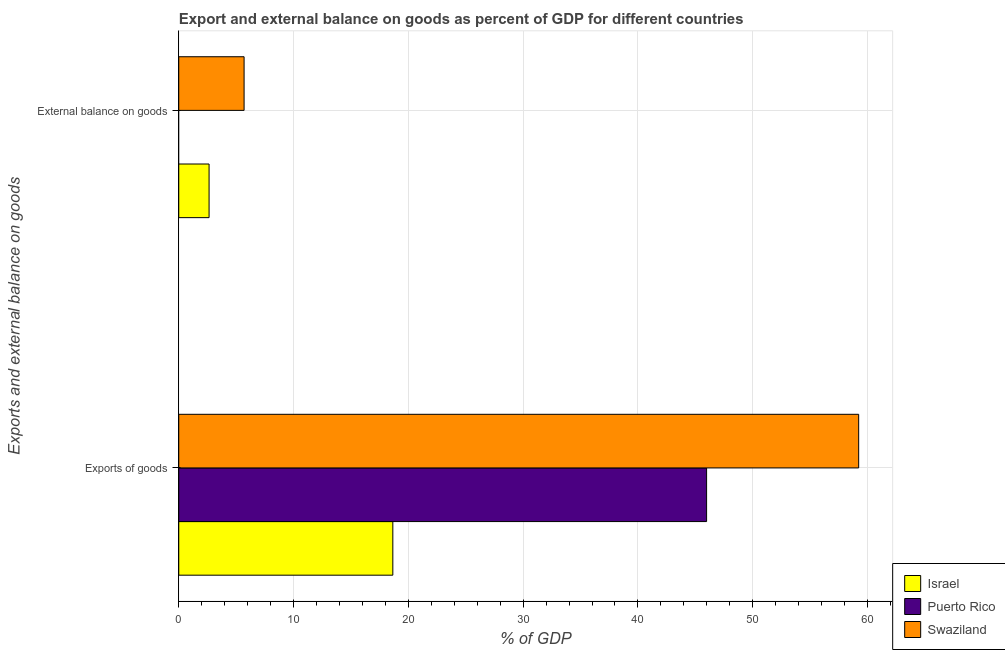Are the number of bars on each tick of the Y-axis equal?
Keep it short and to the point. No. What is the label of the 1st group of bars from the top?
Provide a short and direct response. External balance on goods. What is the export of goods as percentage of gdp in Swaziland?
Provide a short and direct response. 59.23. Across all countries, what is the maximum external balance on goods as percentage of gdp?
Offer a very short reply. 5.69. Across all countries, what is the minimum external balance on goods as percentage of gdp?
Provide a succinct answer. 0. In which country was the export of goods as percentage of gdp maximum?
Ensure brevity in your answer.  Swaziland. What is the total external balance on goods as percentage of gdp in the graph?
Offer a terse response. 8.33. What is the difference between the export of goods as percentage of gdp in Swaziland and that in Israel?
Offer a very short reply. 40.58. What is the difference between the external balance on goods as percentage of gdp in Israel and the export of goods as percentage of gdp in Swaziland?
Ensure brevity in your answer.  -56.59. What is the average external balance on goods as percentage of gdp per country?
Make the answer very short. 2.78. What is the difference between the external balance on goods as percentage of gdp and export of goods as percentage of gdp in Israel?
Give a very brief answer. -16.01. In how many countries, is the external balance on goods as percentage of gdp greater than 18 %?
Keep it short and to the point. 0. What is the ratio of the external balance on goods as percentage of gdp in Israel to that in Swaziland?
Your answer should be very brief. 0.46. How many bars are there?
Give a very brief answer. 5. Are all the bars in the graph horizontal?
Keep it short and to the point. Yes. How many countries are there in the graph?
Keep it short and to the point. 3. What is the difference between two consecutive major ticks on the X-axis?
Keep it short and to the point. 10. Are the values on the major ticks of X-axis written in scientific E-notation?
Keep it short and to the point. No. Does the graph contain grids?
Make the answer very short. Yes. How many legend labels are there?
Give a very brief answer. 3. How are the legend labels stacked?
Provide a succinct answer. Vertical. What is the title of the graph?
Your answer should be very brief. Export and external balance on goods as percent of GDP for different countries. What is the label or title of the X-axis?
Your answer should be very brief. % of GDP. What is the label or title of the Y-axis?
Ensure brevity in your answer.  Exports and external balance on goods. What is the % of GDP of Israel in Exports of goods?
Provide a succinct answer. 18.65. What is the % of GDP of Puerto Rico in Exports of goods?
Provide a succinct answer. 45.98. What is the % of GDP of Swaziland in Exports of goods?
Provide a short and direct response. 59.23. What is the % of GDP in Israel in External balance on goods?
Provide a short and direct response. 2.64. What is the % of GDP of Puerto Rico in External balance on goods?
Your answer should be very brief. 0. What is the % of GDP in Swaziland in External balance on goods?
Make the answer very short. 5.69. Across all Exports and external balance on goods, what is the maximum % of GDP in Israel?
Your answer should be compact. 18.65. Across all Exports and external balance on goods, what is the maximum % of GDP in Puerto Rico?
Your answer should be very brief. 45.98. Across all Exports and external balance on goods, what is the maximum % of GDP in Swaziland?
Provide a succinct answer. 59.23. Across all Exports and external balance on goods, what is the minimum % of GDP of Israel?
Offer a terse response. 2.64. Across all Exports and external balance on goods, what is the minimum % of GDP of Puerto Rico?
Keep it short and to the point. 0. Across all Exports and external balance on goods, what is the minimum % of GDP in Swaziland?
Your answer should be very brief. 5.69. What is the total % of GDP in Israel in the graph?
Provide a short and direct response. 21.29. What is the total % of GDP of Puerto Rico in the graph?
Your answer should be compact. 45.98. What is the total % of GDP in Swaziland in the graph?
Provide a short and direct response. 64.92. What is the difference between the % of GDP of Israel in Exports of goods and that in External balance on goods?
Your response must be concise. 16.01. What is the difference between the % of GDP of Swaziland in Exports of goods and that in External balance on goods?
Your answer should be very brief. 53.54. What is the difference between the % of GDP of Israel in Exports of goods and the % of GDP of Swaziland in External balance on goods?
Your response must be concise. 12.96. What is the difference between the % of GDP of Puerto Rico in Exports of goods and the % of GDP of Swaziland in External balance on goods?
Provide a short and direct response. 40.29. What is the average % of GDP of Israel per Exports and external balance on goods?
Your answer should be very brief. 10.64. What is the average % of GDP of Puerto Rico per Exports and external balance on goods?
Offer a terse response. 22.99. What is the average % of GDP in Swaziland per Exports and external balance on goods?
Provide a short and direct response. 32.46. What is the difference between the % of GDP of Israel and % of GDP of Puerto Rico in Exports of goods?
Offer a terse response. -27.33. What is the difference between the % of GDP in Israel and % of GDP in Swaziland in Exports of goods?
Your response must be concise. -40.58. What is the difference between the % of GDP in Puerto Rico and % of GDP in Swaziland in Exports of goods?
Your answer should be very brief. -13.25. What is the difference between the % of GDP in Israel and % of GDP in Swaziland in External balance on goods?
Ensure brevity in your answer.  -3.05. What is the ratio of the % of GDP in Israel in Exports of goods to that in External balance on goods?
Your answer should be compact. 7.06. What is the ratio of the % of GDP of Swaziland in Exports of goods to that in External balance on goods?
Provide a succinct answer. 10.41. What is the difference between the highest and the second highest % of GDP in Israel?
Your answer should be compact. 16.01. What is the difference between the highest and the second highest % of GDP in Swaziland?
Offer a very short reply. 53.54. What is the difference between the highest and the lowest % of GDP of Israel?
Make the answer very short. 16.01. What is the difference between the highest and the lowest % of GDP in Puerto Rico?
Your answer should be very brief. 45.98. What is the difference between the highest and the lowest % of GDP of Swaziland?
Give a very brief answer. 53.54. 